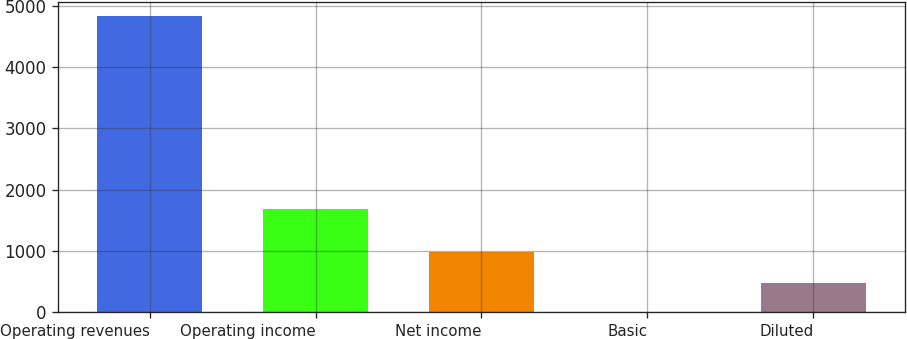<chart> <loc_0><loc_0><loc_500><loc_500><bar_chart><fcel>Operating revenues<fcel>Operating income<fcel>Net income<fcel>Basic<fcel>Diluted<nl><fcel>4829<fcel>1687<fcel>979<fcel>1.16<fcel>483.94<nl></chart> 